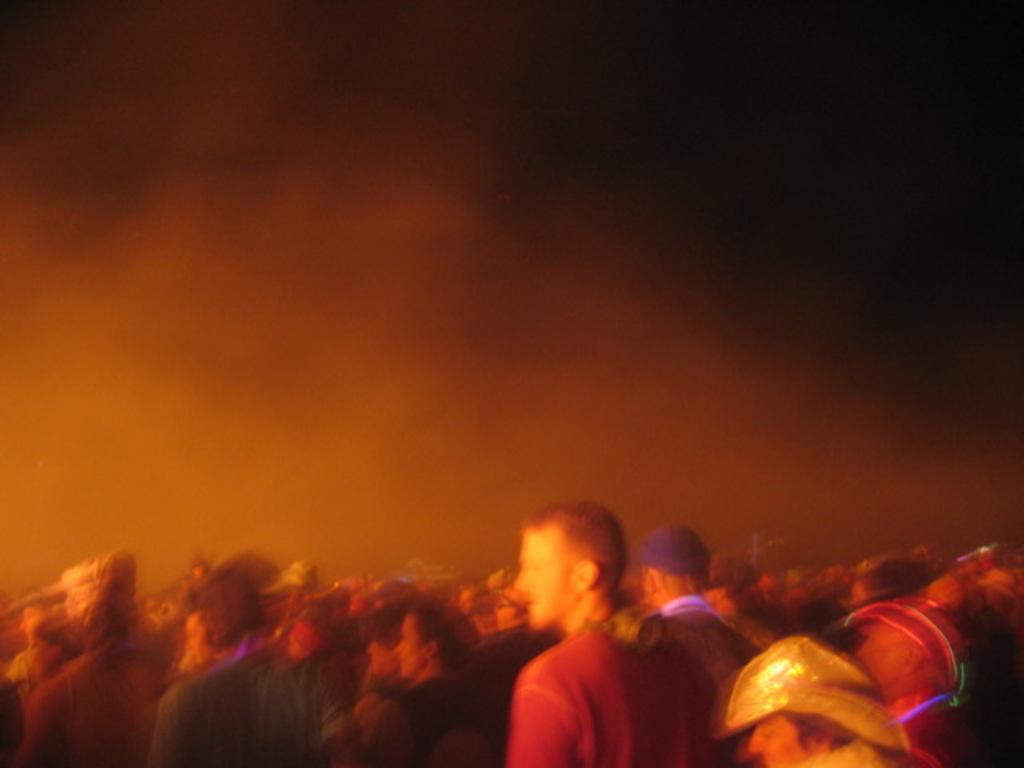In one or two sentences, can you explain what this image depicts? At the bottom of the image few people are standing. In the middle of the image we can see fog. 